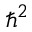<formula> <loc_0><loc_0><loc_500><loc_500>\hbar { ^ } { 2 }</formula> 